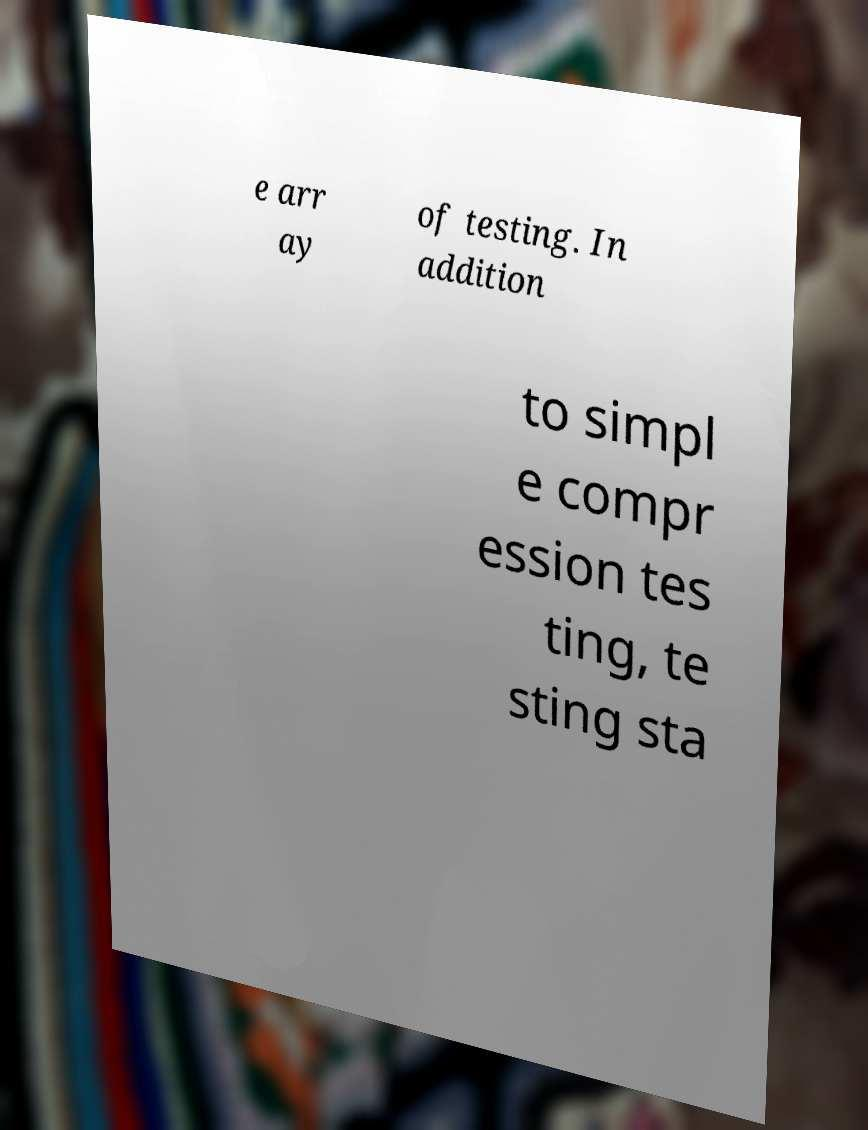Could you extract and type out the text from this image? e arr ay of testing. In addition to simpl e compr ession tes ting, te sting sta 